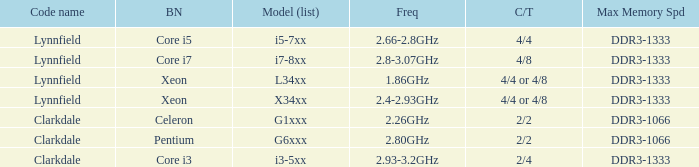List the number of cores for ddr3-1333 with frequencies between 2.66-2.8ghz. 4/4. 